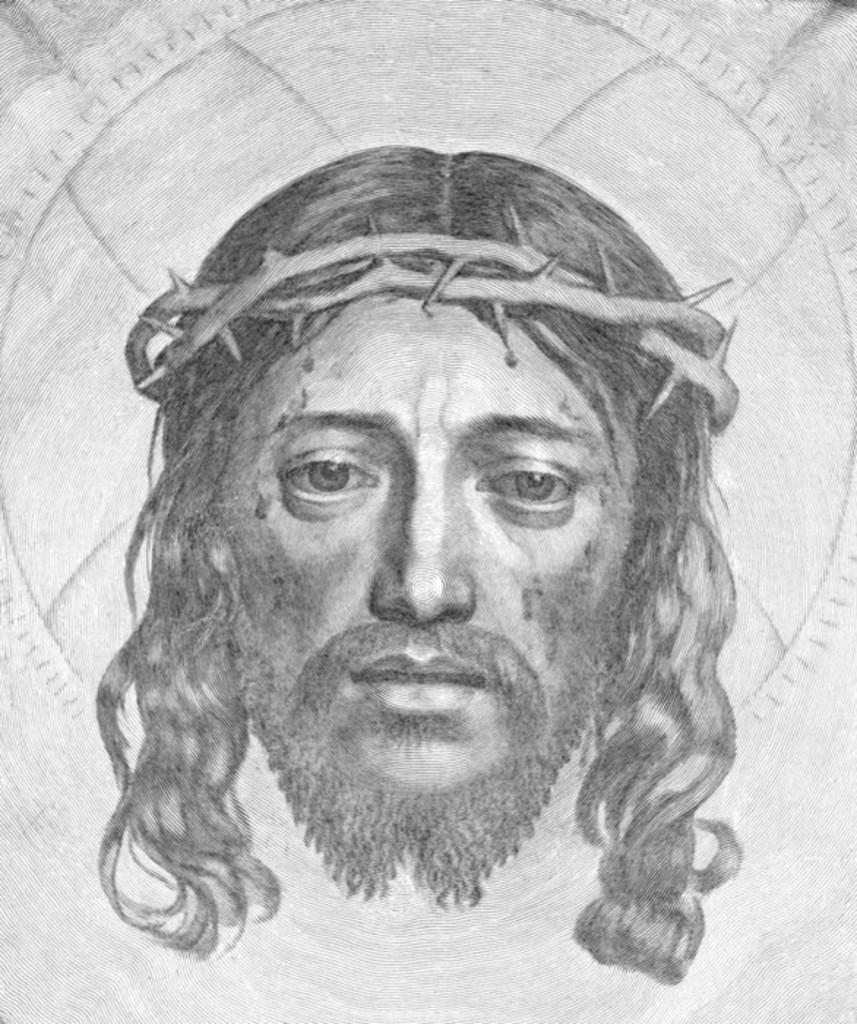In one or two sentences, can you explain what this image depicts? In this picture we can see a drawing of a person. 